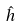<formula> <loc_0><loc_0><loc_500><loc_500>\hat { h }</formula> 